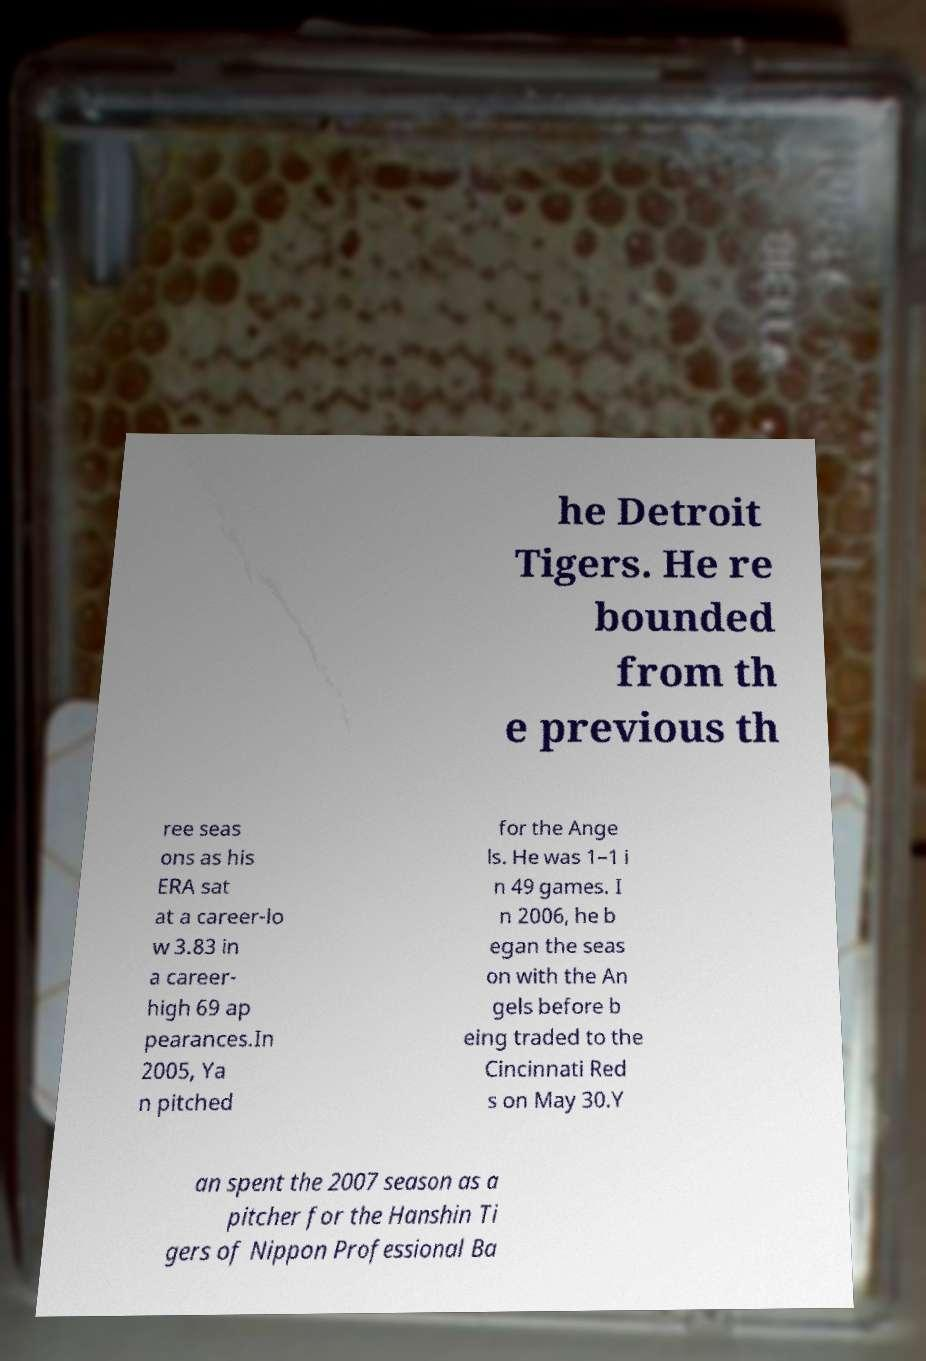Can you read and provide the text displayed in the image?This photo seems to have some interesting text. Can you extract and type it out for me? he Detroit Tigers. He re bounded from th e previous th ree seas ons as his ERA sat at a career-lo w 3.83 in a career- high 69 ap pearances.In 2005, Ya n pitched for the Ange ls. He was 1–1 i n 49 games. I n 2006, he b egan the seas on with the An gels before b eing traded to the Cincinnati Red s on May 30.Y an spent the 2007 season as a pitcher for the Hanshin Ti gers of Nippon Professional Ba 